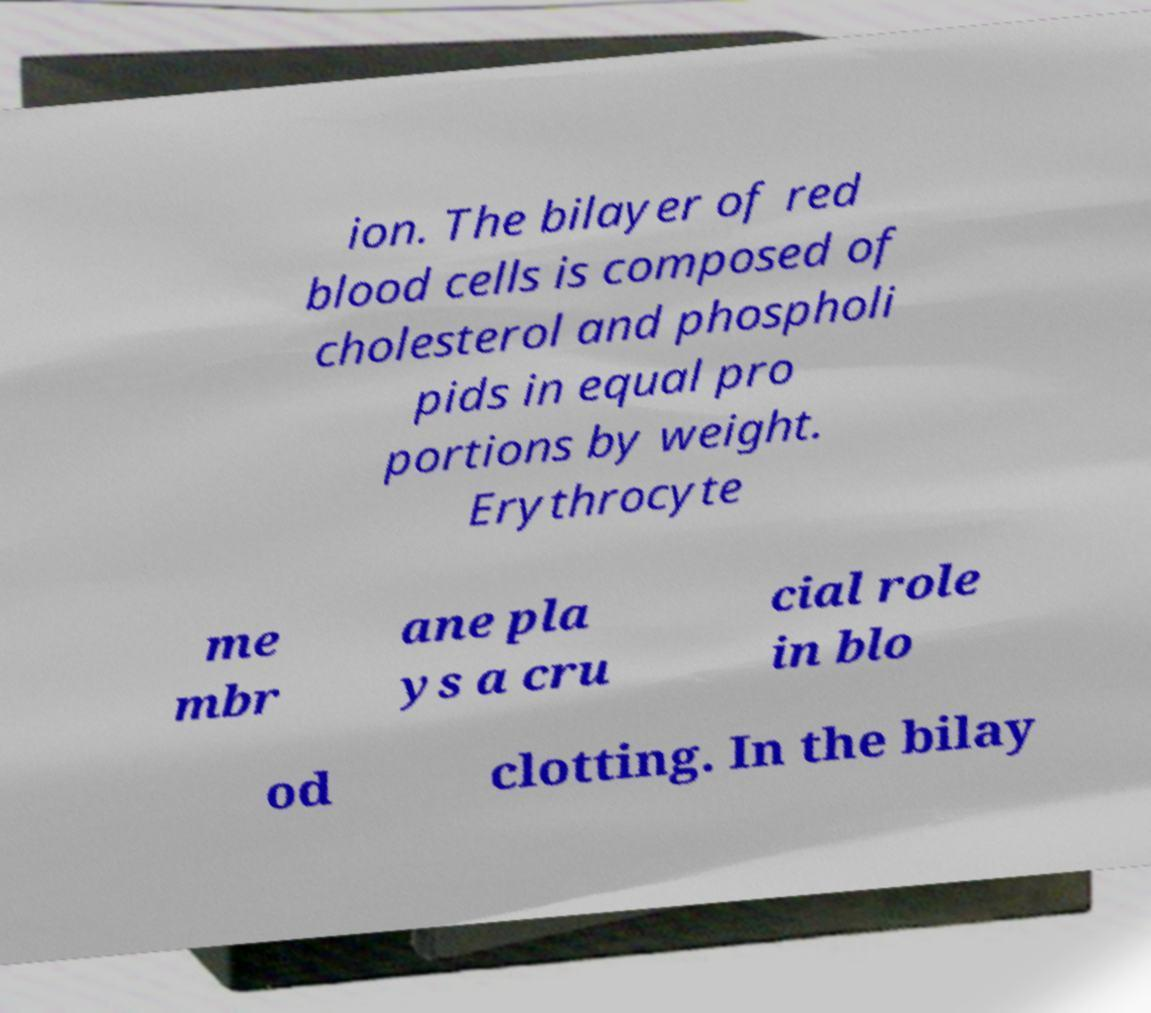For documentation purposes, I need the text within this image transcribed. Could you provide that? ion. The bilayer of red blood cells is composed of cholesterol and phospholi pids in equal pro portions by weight. Erythrocyte me mbr ane pla ys a cru cial role in blo od clotting. In the bilay 